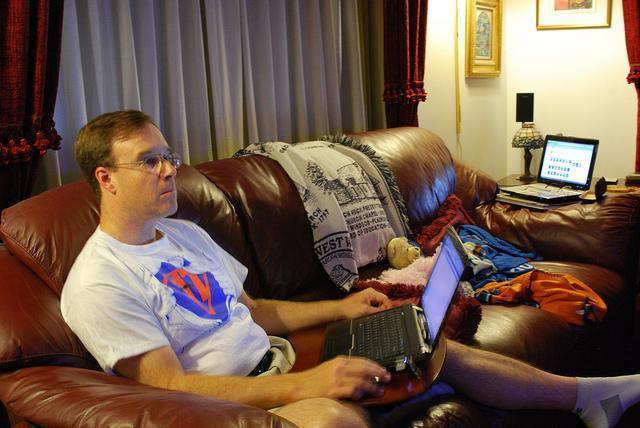How many laptops are visible?
Give a very brief answer. 2. How many people are visible?
Give a very brief answer. 1. How many laptops are there?
Give a very brief answer. 2. 